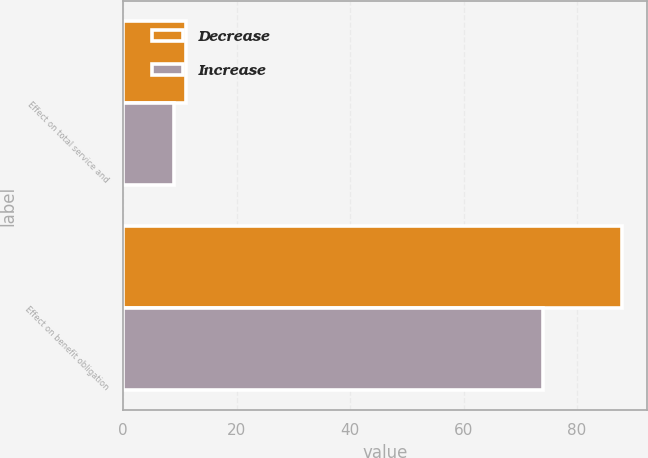Convert chart to OTSL. <chart><loc_0><loc_0><loc_500><loc_500><stacked_bar_chart><ecel><fcel>Effect on total service and<fcel>Effect on benefit obligation<nl><fcel>Decrease<fcel>11<fcel>88<nl><fcel>Increase<fcel>9<fcel>74<nl></chart> 